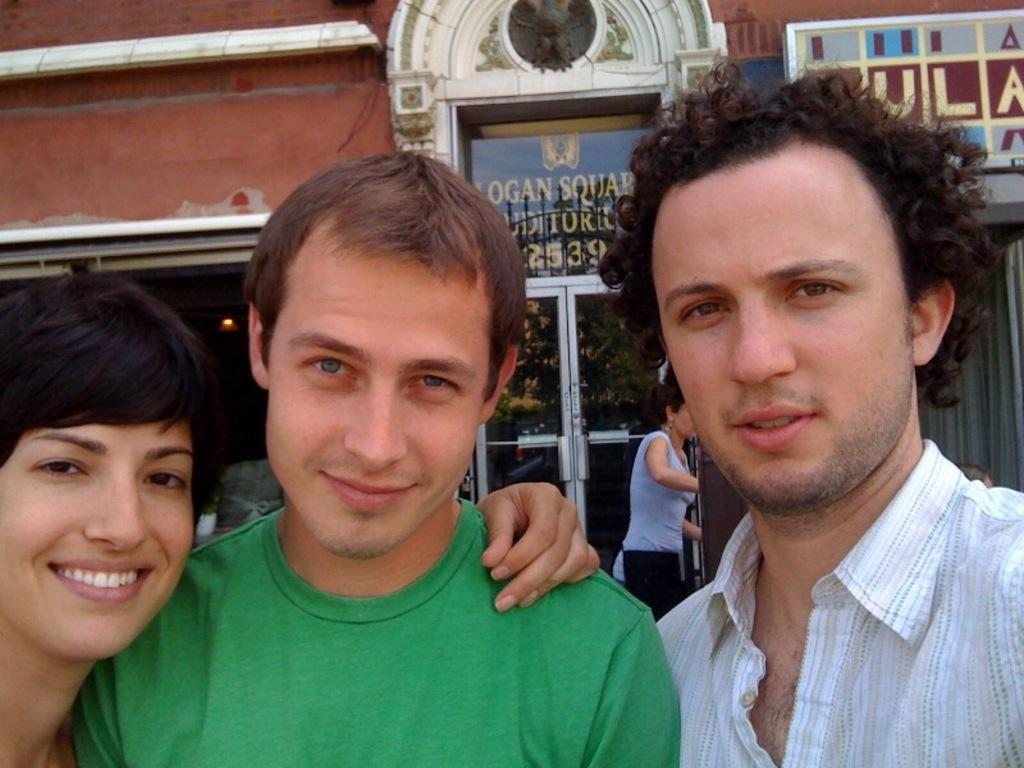How many people are in the image? There are people in the image, but the exact number is not specified. What is the facial expression of some people in the front? Some people in the front are smiling. What can be seen in the background of the image? There is a building and a glass door in the background of the image. What is written on the building? Something is written on the building, but the specific text is not mentioned. What type of pen is being used to write on the building in the image? There is no pen present in the image, and nothing is mentioned about writing on the building. 